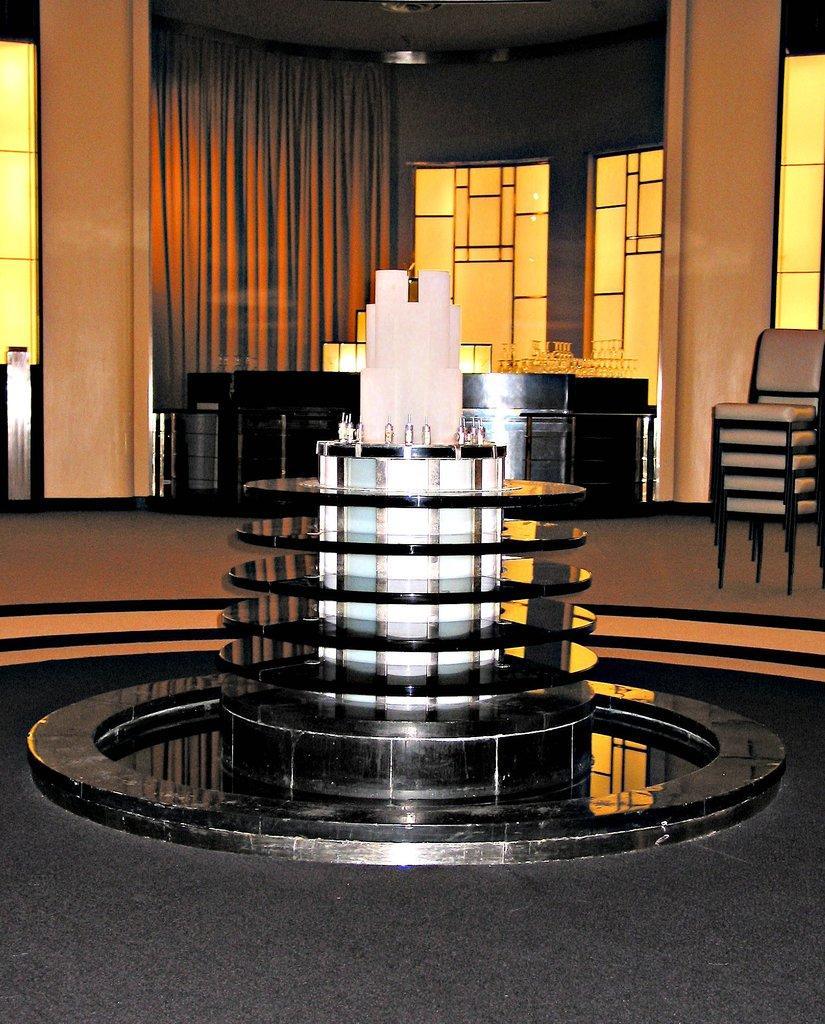How would you summarize this image in a sentence or two? In this image in the front there is a fountain. In the background there is a curtain and there are chairs and there is a table. 